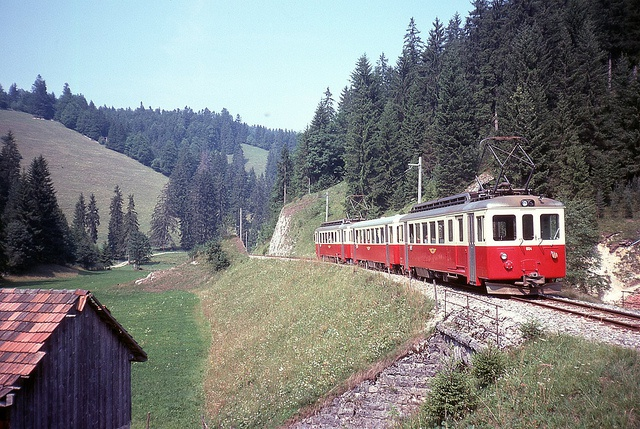Describe the objects in this image and their specific colors. I can see a train in lightblue, white, salmon, darkgray, and black tones in this image. 